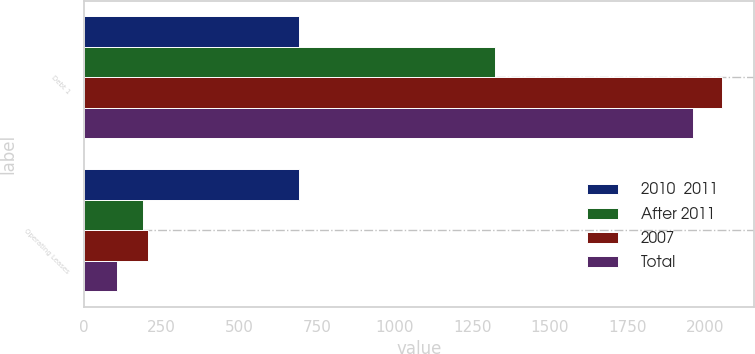Convert chart. <chart><loc_0><loc_0><loc_500><loc_500><stacked_bar_chart><ecel><fcel>Debt 1<fcel>Operating Leases<nl><fcel>2010  2011<fcel>691<fcel>691<nl><fcel>After 2011<fcel>1322<fcel>191<nl><fcel>2007<fcel>2055<fcel>205<nl><fcel>Total<fcel>1961<fcel>106<nl></chart> 